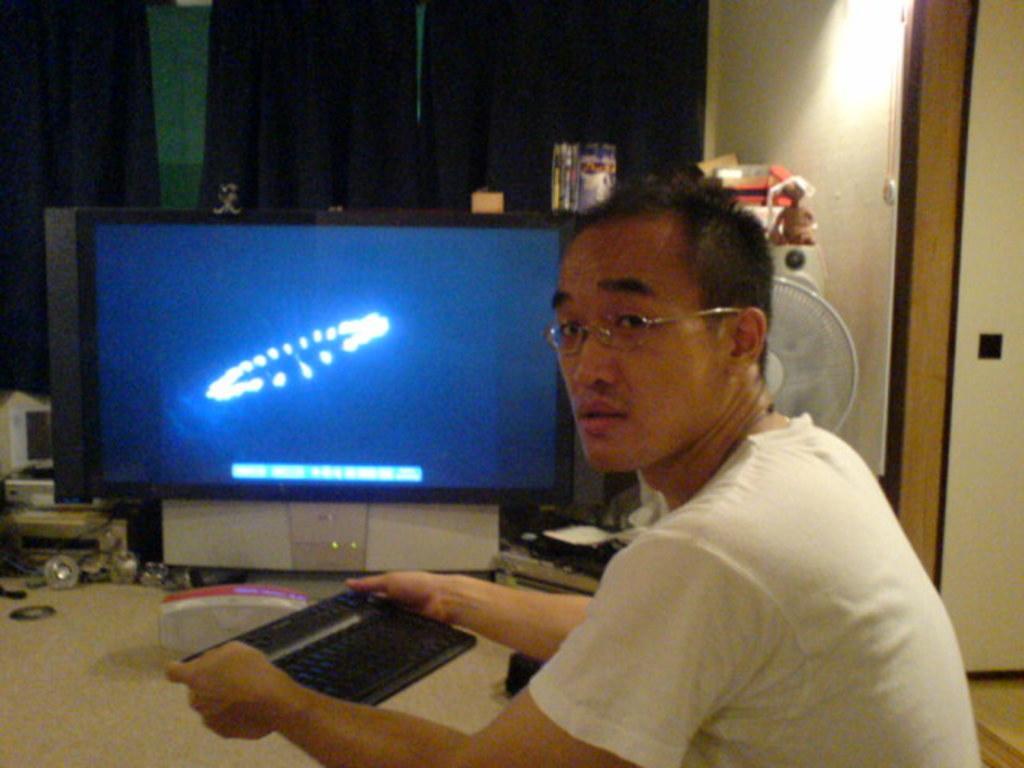How would you summarize this image in a sentence or two? There is a person in white color t-shirt, holding a keyboard with both hands and sitting on the floor. In the background, there is a monitor on the table, there is a fan, there is a curtain near white wall and there are other objects. 